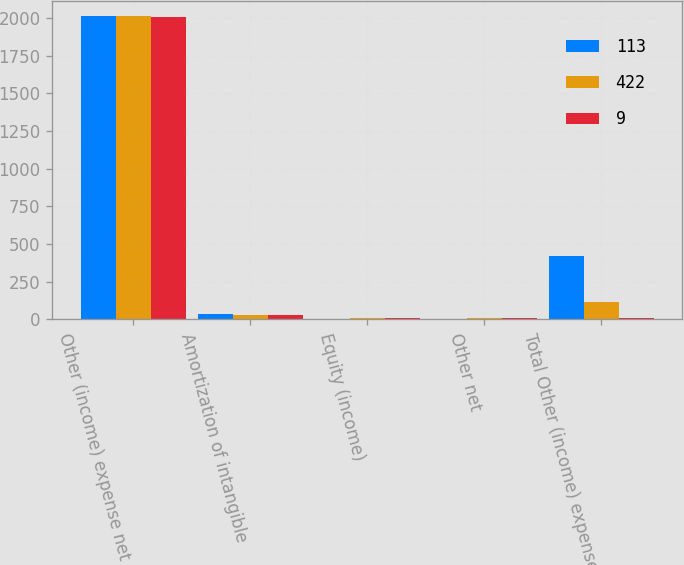<chart> <loc_0><loc_0><loc_500><loc_500><stacked_bar_chart><ecel><fcel>Other (income) expense net<fcel>Amortization of intangible<fcel>Equity (income)<fcel>Other net<fcel>Total Other (income) expense<nl><fcel>113<fcel>2013<fcel>32<fcel>5<fcel>5<fcel>422<nl><fcel>422<fcel>2012<fcel>31<fcel>7<fcel>6<fcel>113<nl><fcel>9<fcel>2011<fcel>28<fcel>6<fcel>6<fcel>9<nl></chart> 